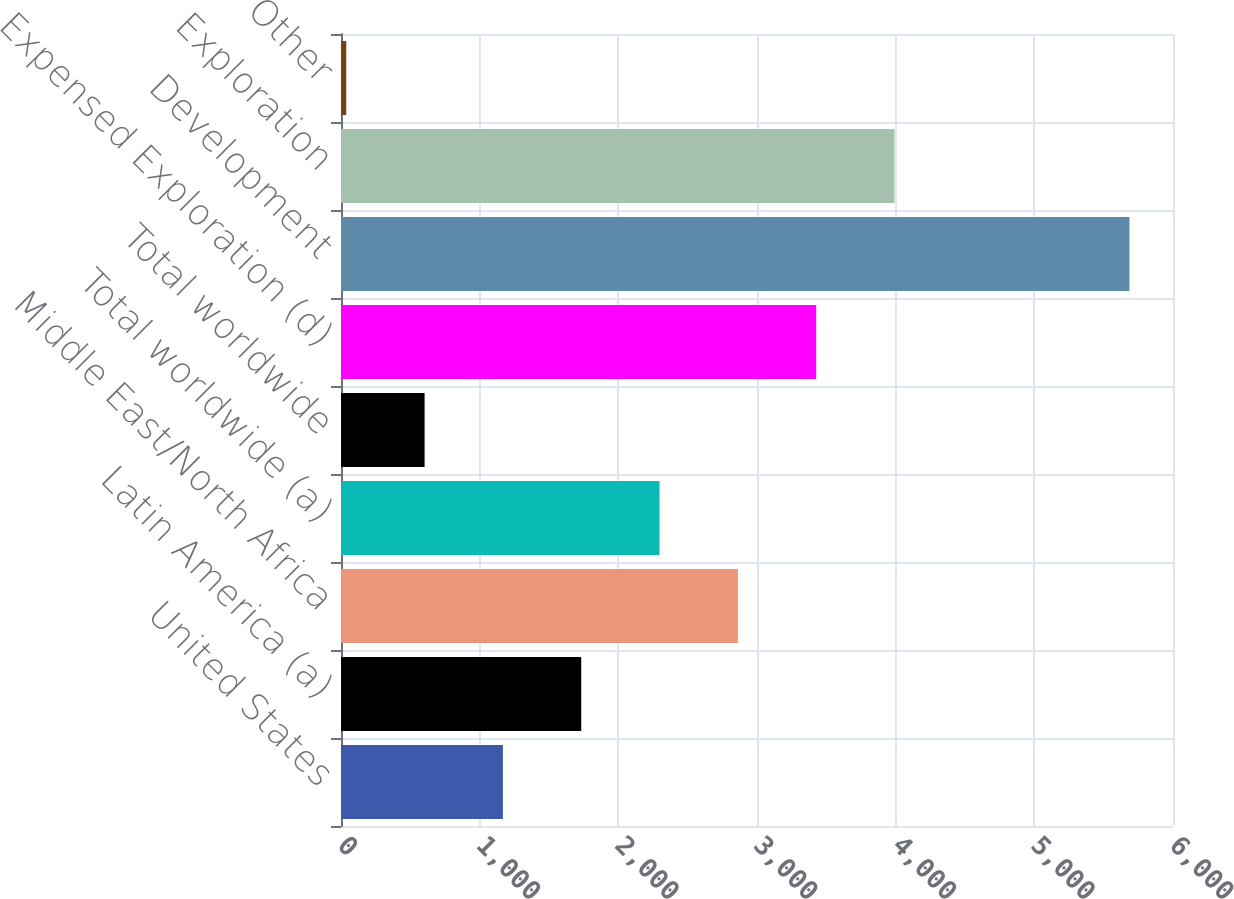Convert chart to OTSL. <chart><loc_0><loc_0><loc_500><loc_500><bar_chart><fcel>United States<fcel>Latin America (a)<fcel>Middle East/North Africa<fcel>Total worldwide (a)<fcel>Total worldwide<fcel>Expensed Exploration (d)<fcel>Development<fcel>Exploration<fcel>Other<nl><fcel>1167.6<fcel>1732.4<fcel>2862<fcel>2297.2<fcel>602.8<fcel>3426.8<fcel>5686<fcel>3991.6<fcel>38<nl></chart> 